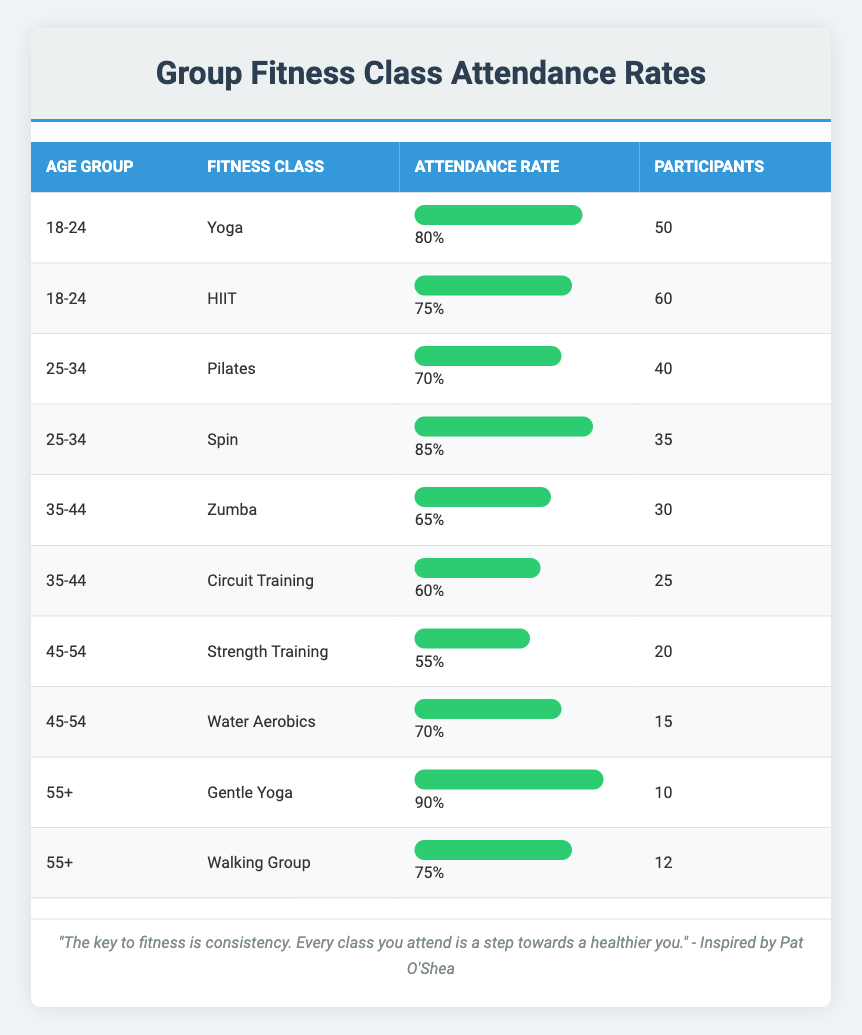What is the attendance rate for the Yoga class in the 18-24 age group? The attendance rate for the Yoga class is stated directly in the table under the "Attendance Rate" column for the "18-24" age group. It shows an attendance rate of 80%.
Answer: 80% Which age group has the highest attendance rate for any fitness class? By reviewing the "Attendance Rate" column, Gentle Yoga for the 55+ age group shows an attendance rate of 90%, which is the highest across all age groups.
Answer: 55+ How many participants attended the HIIT class in the 18-24 age group? The number of participants for the HIIT class is indicated in the "Participants" column for the "18-24" age group, which lists 60 participants.
Answer: 60 What is the average attendance rate for the fitness classes in the 35-44 age group? The attendance rates for the 35-44 age group are 65% for Zumba and 60% for Circuit Training. Sum these rates: 65 + 60 = 125. Then divide by 2 (the number of classes): 125/2 = 62.5%.
Answer: 62.5% Is the attendance rate for Water Aerobics higher than Strength Training in the 45-54 age group? Water Aerobics has an attendance rate of 70% and Strength Training has 55%. Since 70% is greater than 55%, this statement is true.
Answer: Yes Which fitness class has the lowest attendance rate in the 25-34 age group? In the 25-34 age group, the attendance rates are 70% for Pilates and 85% for Spin. Since 70% for Pilates is lower, it is the lowest attendance rate in this group.
Answer: Pilates What is the total number of participants across all classes in the 55+ age group? The participants in the 55+ age group include 10 for Gentle Yoga and 12 for Walking Group. Adding these two together gives us 10 + 12 = 22 participants.
Answer: 22 Do both classes in the 45-54 age group have attendance rates below 60%? The attendance rates for the 45-54 age group are 55% for Strength Training and 70% for Water Aerobics. Since 70% is not below 60%, the statement is false.
Answer: No For the 18-24 age group, what percentage of attendees participated in the Yoga class compared to the entire attendance for that age group? The total participants in the 18-24 age group are 50 (Yoga) + 60 (HIIT) = 110. The Yoga class has 50 participants. To find the percentage: (50/110) * 100 = 45.45%, approximately 45%.
Answer: 45% 